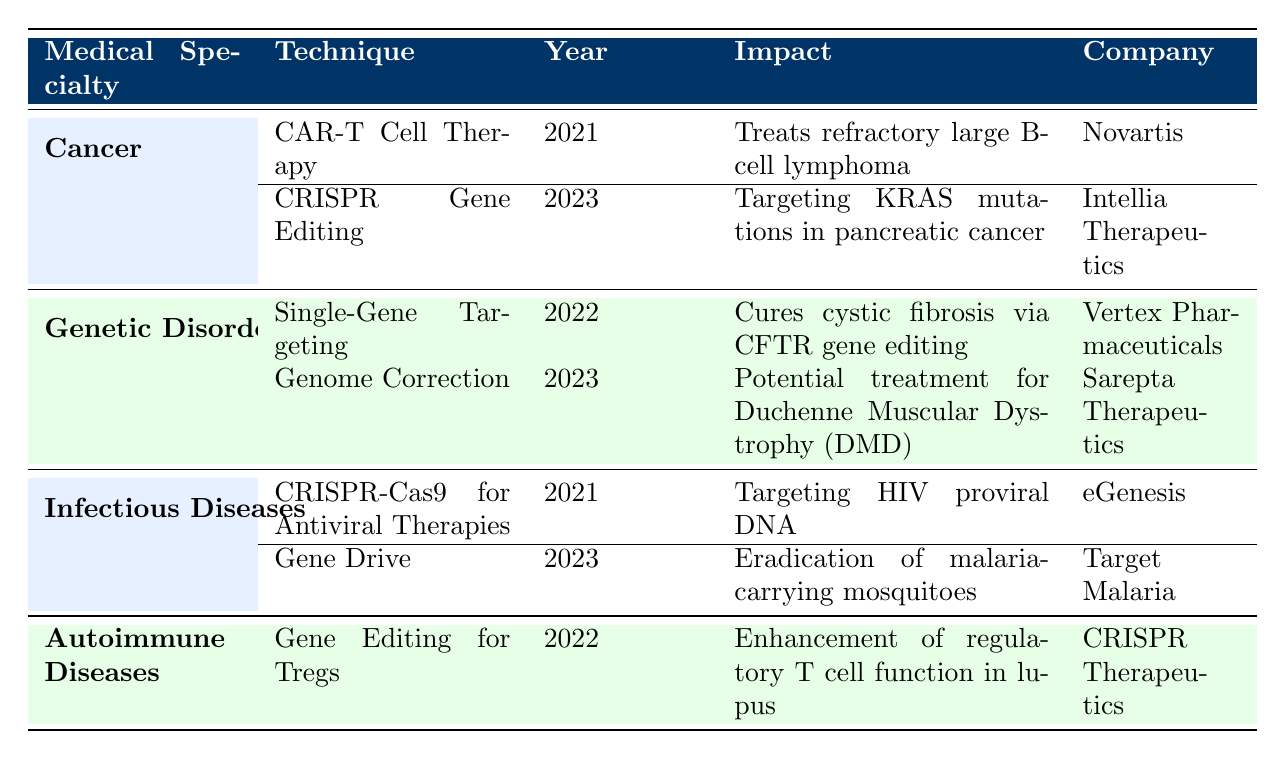What are the two techniques used for cancer treatment listed in the table? The table under the "Cancer" specialty lists two techniques: CAR-T Cell Therapy and CRISPR Gene Editing.
Answer: CAR-T Cell Therapy, CRISPR Gene Editing Which company developed the treatment for cystic fibrosis? The table indicates that Vertex Pharmaceuticals developed Single-Gene Targeting for cystic fibrosis.
Answer: Vertex Pharmaceuticals In what year was Gene Editing for Tregs applied to autoimmune diseases? The table shows that Gene Editing for Tregs was applied in the year 2022.
Answer: 2022 Is Gene Drive used to target HIV in the applications listed? According to the table, Gene Drive is not used for targeting HIV; rather, CRISPR-Cas9 for Antiviral Therapies is the applicable technique for HIV targeting.
Answer: No What is the impact of the technique applied by Sarepta Therapeutics? The impact of the technique "Genome Correction" by Sarepta Therapeutics is listed as a potential treatment for Duchenne Muscular Dystrophy (DMD).
Answer: Potential treatment for Duchenne Muscular Dystrophy (DMD) How many applications in total were recorded in the field of Infectious Diseases? The field of Infectious Diseases has two applications recorded: CRISPR-Cas9 for Antiviral Therapies and Gene Drive.
Answer: 2 Which medical specialty had an application released in 2023 that targets KRAS mutations? The medical specialty that had an application in 2023 targeting KRAS mutations is Cancer, specifically using CRISPR Gene Editing.
Answer: Cancer What is the year range for the applications listed in the table? The applications listed span from 2021 to 2023, with the earliest application in 2021 and the latest in 2023.
Answer: 2021-2023 Which application aims for the eradication of malaria-carrying mosquitoes? The application that aims for the eradication of malaria-carrying mosquitoes is listed as "Gene Drive" developed in 2023 by Target Malaria.
Answer: Gene Drive 